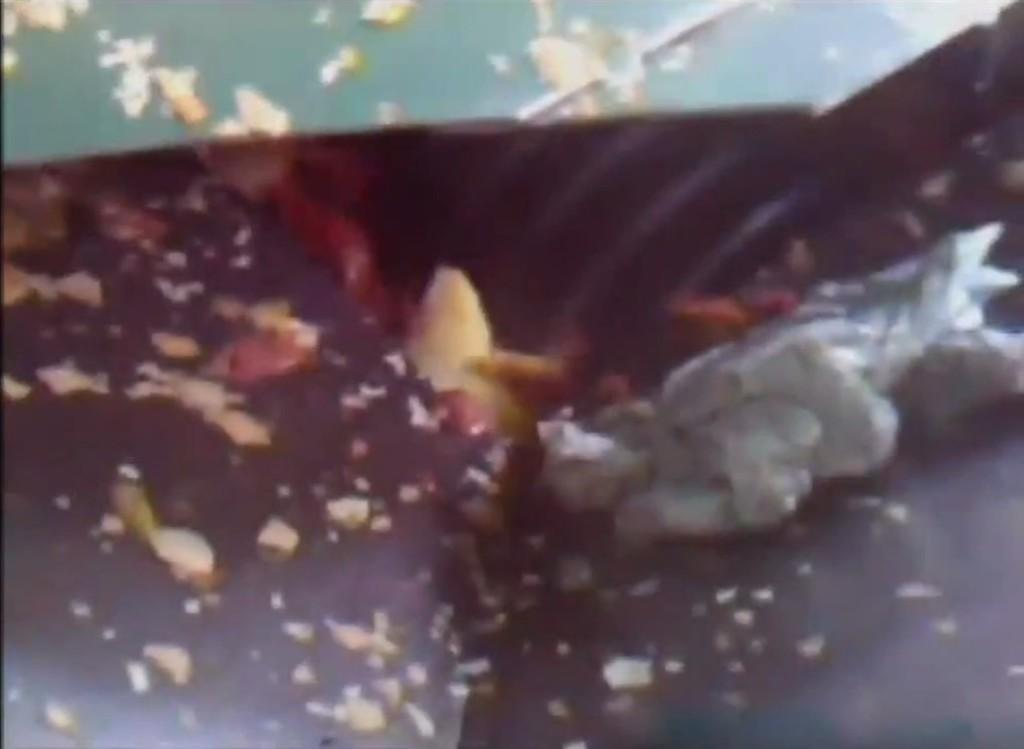What type of cake is shown in the image? There is a chocolate cake in the image. What is on top of the chocolate cake? The chocolate cake is topped with dried fruits. How many eyes can be seen on the chocolate cake in the image? There are no eyes visible on the chocolate cake in the image, as it is a dessert and not a living being. 